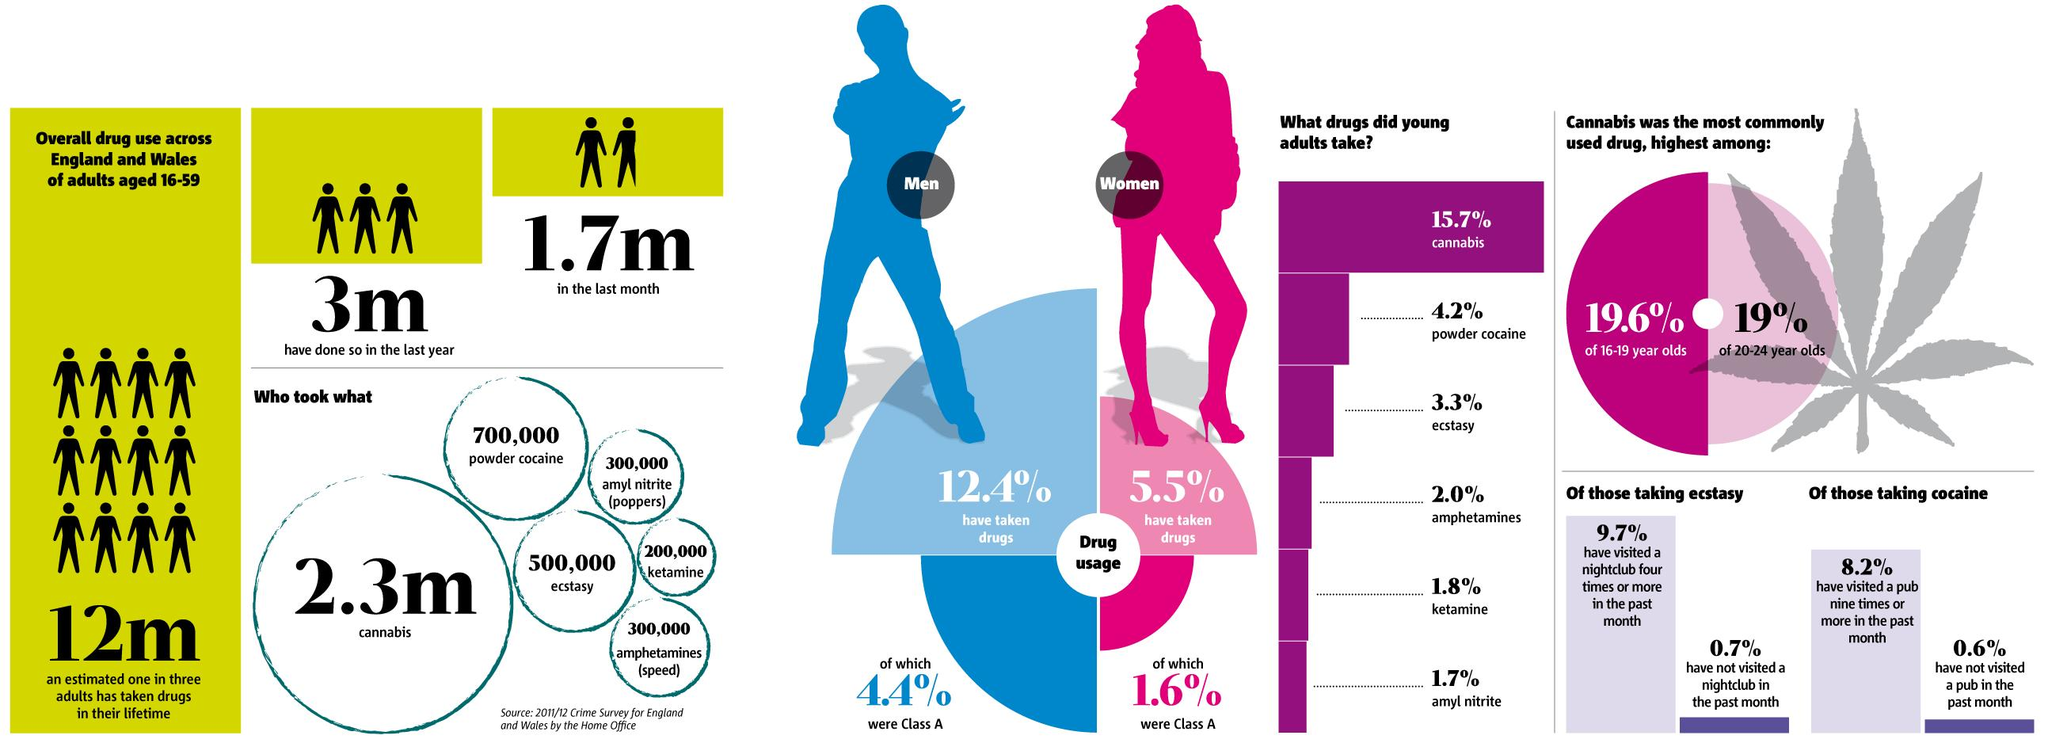Identify some key points in this picture. According to the 2011/2012 crime survey, amyl nitrate (poppers) was the drug that was least used by young adults in England and Wales. According to the 2011/2012 crime survey, 12.4% of men aged 16-59 in England and Wales have taken drugs. A survey conducted in England and Wales in 2011/2012 found that only 1.6% of drugs taken by women aged 16-59 were classified as class A. According to the 2011/2012 crime survey, the estimated number of adults aged 16-59 in England and Wales who used drugs in the last month is 1.7 million. According to the 2011/2012 crime survey, approximately 700,000 people in England and Wales have used powder cocaine. 